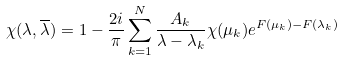<formula> <loc_0><loc_0><loc_500><loc_500>\chi ( \lambda , \overline { \lambda } ) = 1 - \frac { 2 i } { \pi } \sum ^ { N } _ { k = 1 } \frac { A _ { k } } { \lambda - \lambda _ { k } } \chi ( \mu _ { k } ) e ^ { F ( \mu _ { k } ) - F ( \lambda _ { k } ) }</formula> 